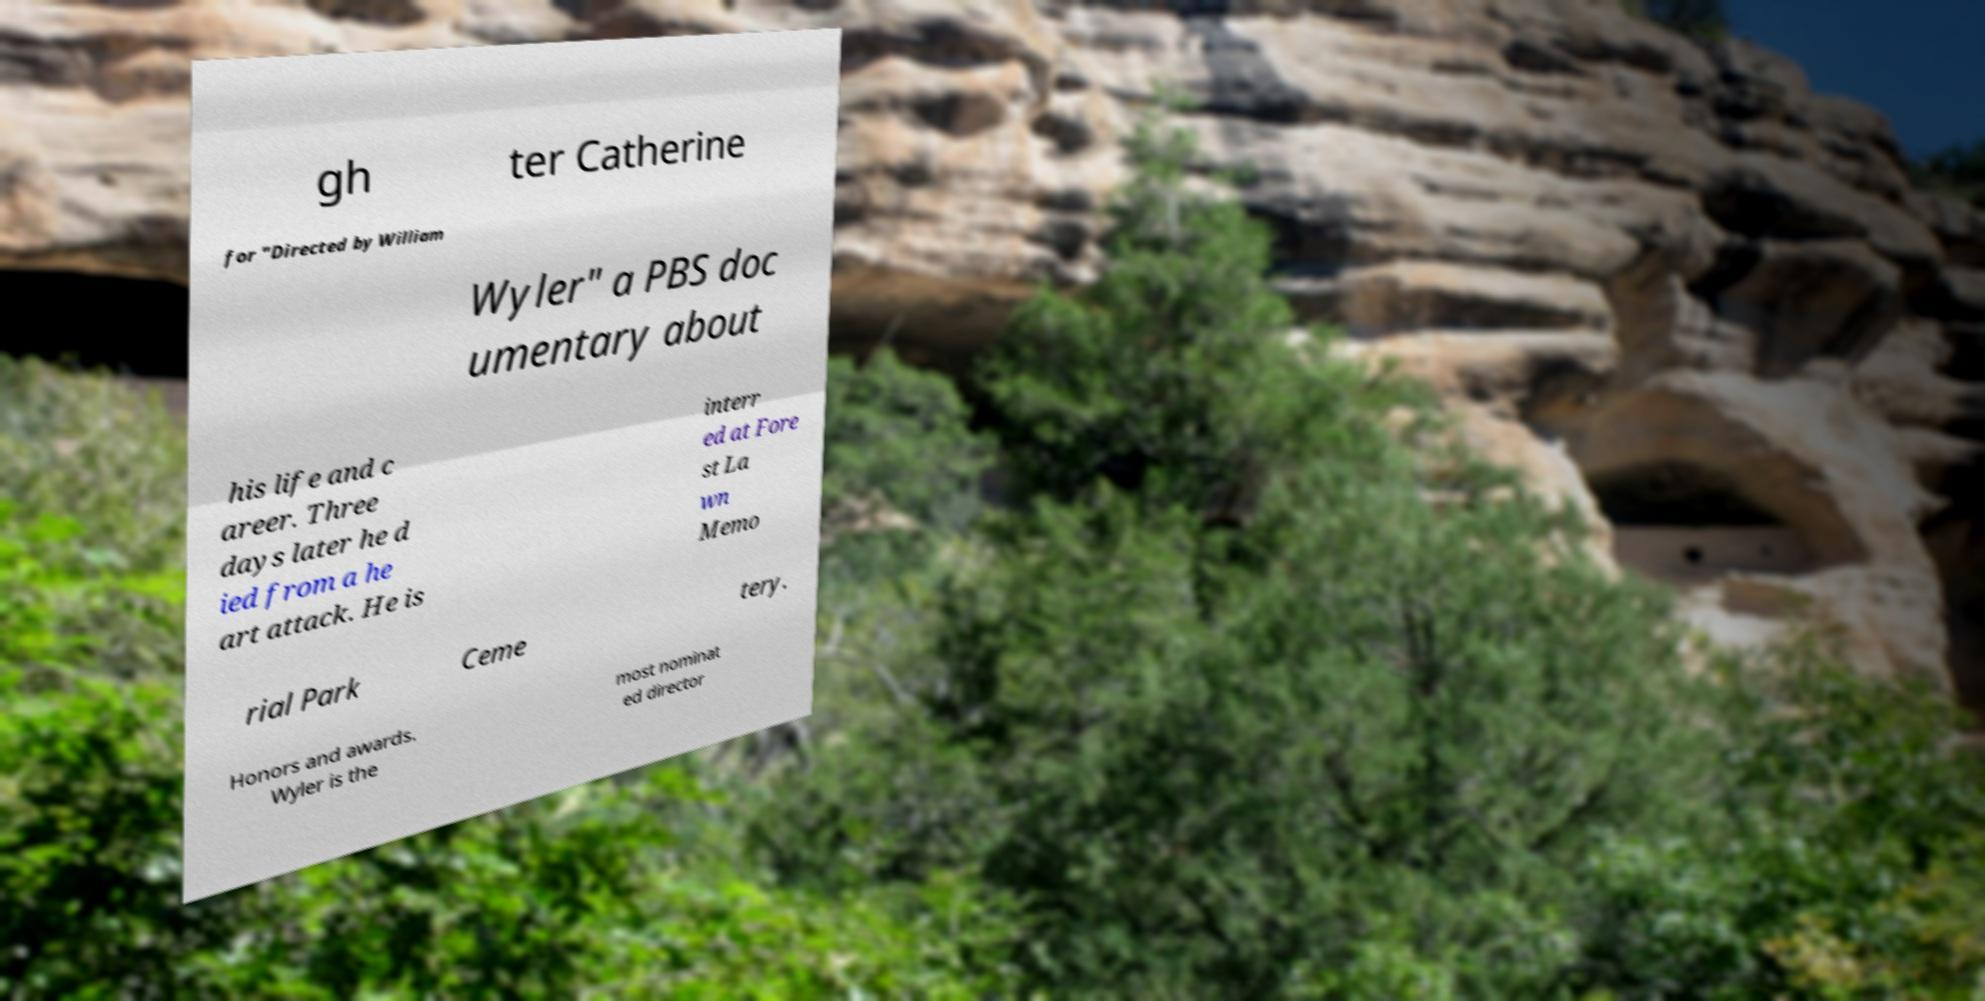Please identify and transcribe the text found in this image. gh ter Catherine for "Directed by William Wyler" a PBS doc umentary about his life and c areer. Three days later he d ied from a he art attack. He is interr ed at Fore st La wn Memo rial Park Ceme tery. Honors and awards. Wyler is the most nominat ed director 